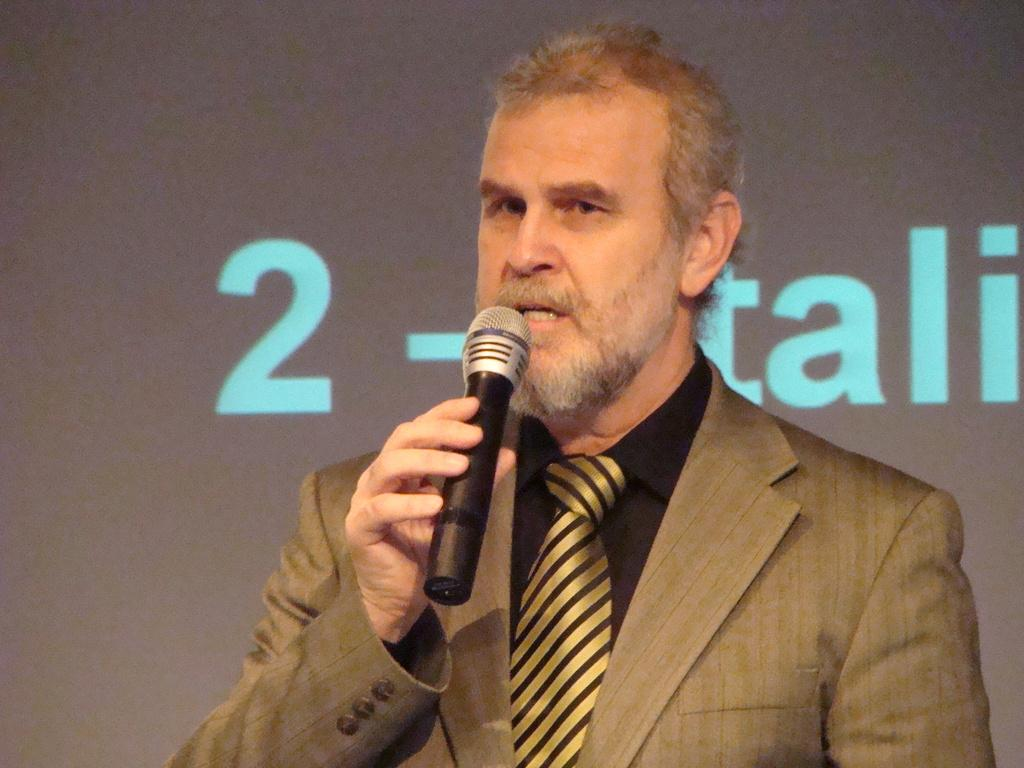What can be seen in the image? There is a person in the image. What is the person wearing? The person is wearing a blazer. What is the person holding? The person is holding a mic. How many trees can be seen in the image? There are no trees visible in the image; it features a person wearing a blazer and holding a mic. 